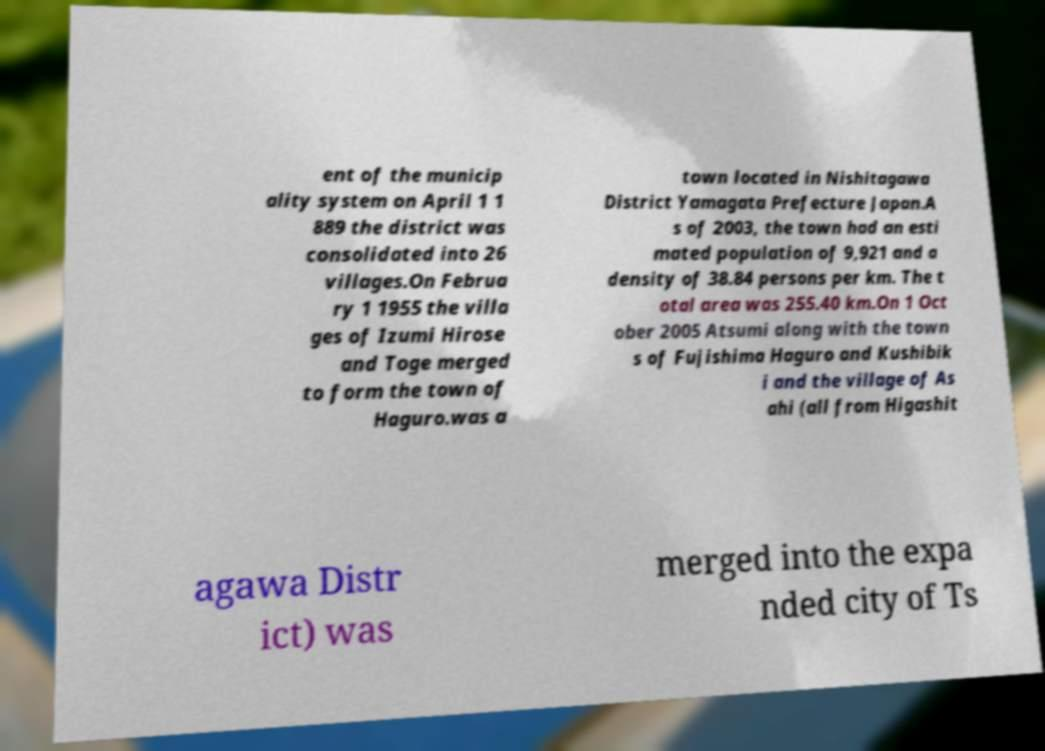Please read and relay the text visible in this image. What does it say? ent of the municip ality system on April 1 1 889 the district was consolidated into 26 villages.On Februa ry 1 1955 the villa ges of Izumi Hirose and Toge merged to form the town of Haguro.was a town located in Nishitagawa District Yamagata Prefecture Japan.A s of 2003, the town had an esti mated population of 9,921 and a density of 38.84 persons per km. The t otal area was 255.40 km.On 1 Oct ober 2005 Atsumi along with the town s of Fujishima Haguro and Kushibik i and the village of As ahi (all from Higashit agawa Distr ict) was merged into the expa nded city of Ts 